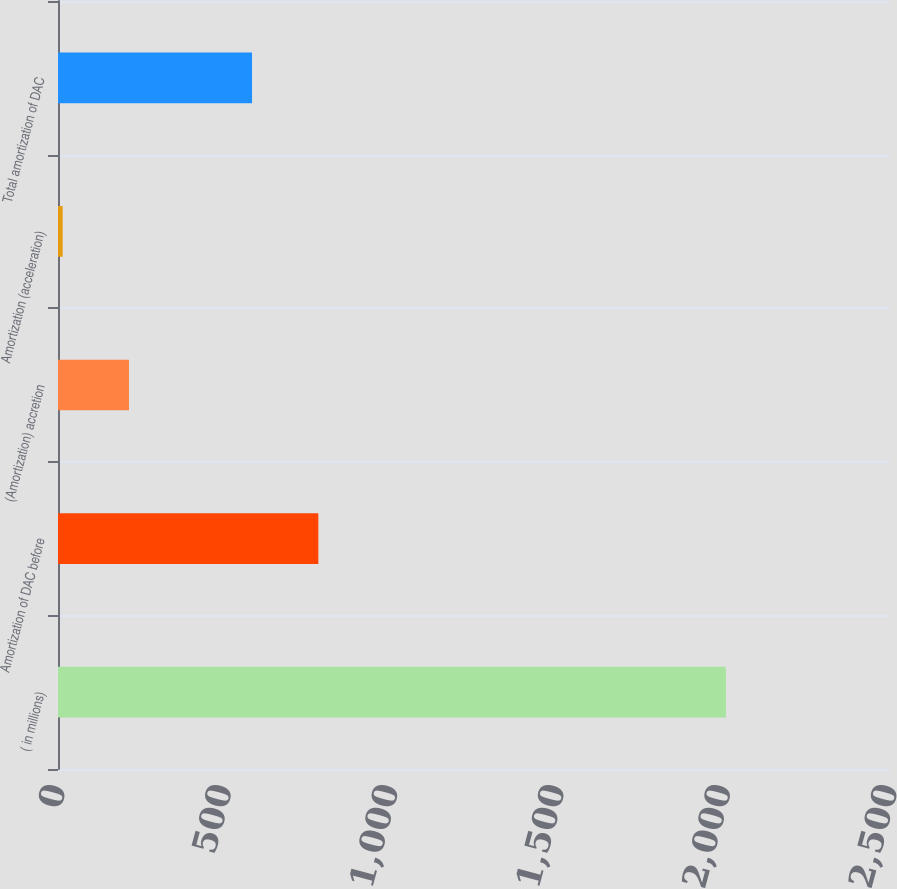Convert chart to OTSL. <chart><loc_0><loc_0><loc_500><loc_500><bar_chart><fcel>( in millions)<fcel>Amortization of DAC before<fcel>(Amortization) accretion<fcel>Amortization (acceleration)<fcel>Total amortization of DAC<nl><fcel>2007<fcel>782.3<fcel>213.3<fcel>14<fcel>583<nl></chart> 